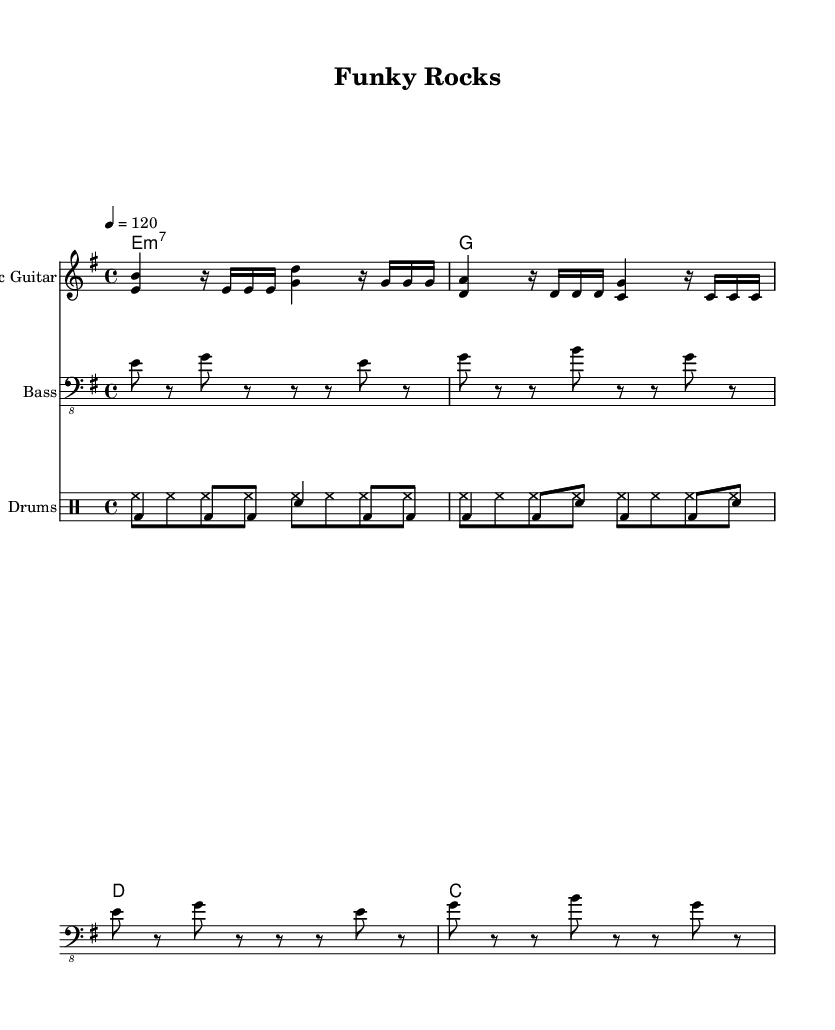What is the key signature of this music? The key signature is E minor, which has one sharp (F#). It is indicated at the beginning of the score within the key signature section.
Answer: E minor What is the time signature of this music? The time signature is 4/4, indicated at the beginning of the score. This means there are four beats per measure, and the quarter note gets one beat.
Answer: 4/4 What is the tempo marking of this piece? The tempo marking is 120 beats per minute, indicated by the "tempo 4 = 120" notation. This tells musicians how fast to play the piece.
Answer: 120 Which instrument plays the bass part? The bass part is played by the bass guitar, as indicated by the label "Bass" in the staff.
Answer: Bass guitar How many measures are there in the bass guitar part? There are four measures in the bass guitar part, which can be counted as the number of groups of vertical lines separating the music.
Answer: Four What type of chords are used in the organ part? The organ part uses minor seventh chords, as indicated by the chord symbols e:m7, g, d, and c in the chord mode section.
Answer: Minor seventh chords What rhythmic pattern does the drum part predominantly use? The drum part predominantly uses a combination of bass drum and snare drum patterns, commonly found in funk and rock music, where the bass drum is emphasized.
Answer: Combination of bass and snare 